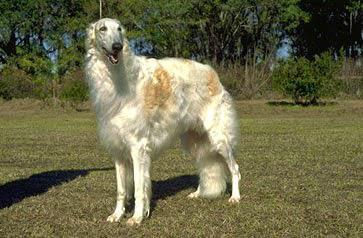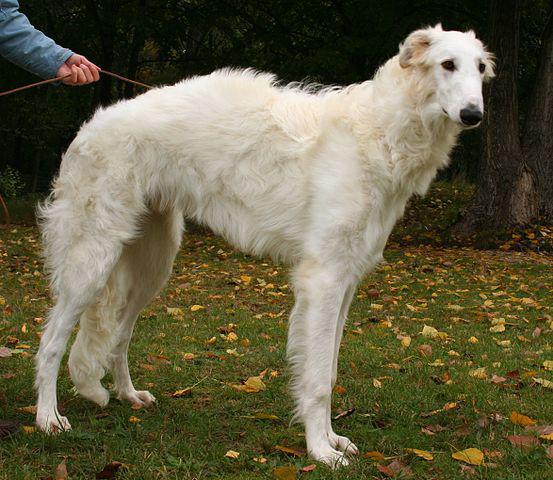The first image is the image on the left, the second image is the image on the right. For the images shown, is this caption "In both images the dog is turned toward the right side of the image." true? Answer yes or no. No. 